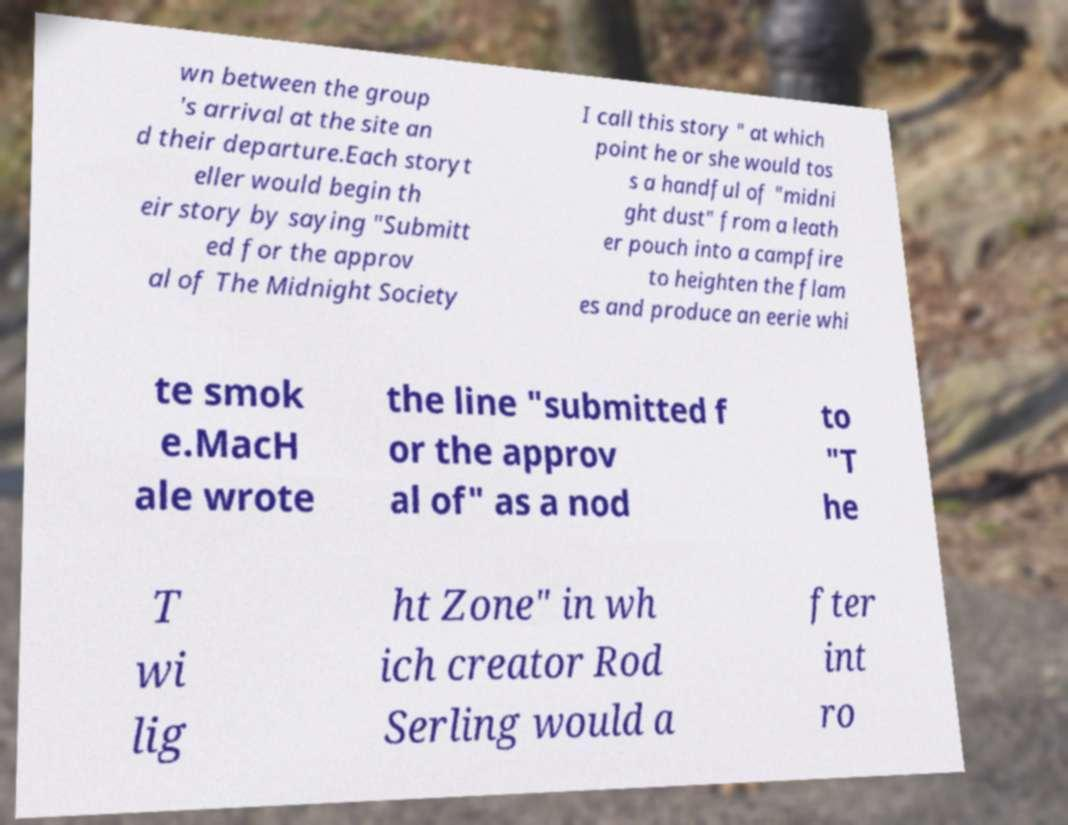Please identify and transcribe the text found in this image. wn between the group 's arrival at the site an d their departure.Each storyt eller would begin th eir story by saying "Submitt ed for the approv al of The Midnight Society I call this story " at which point he or she would tos s a handful of "midni ght dust" from a leath er pouch into a campfire to heighten the flam es and produce an eerie whi te smok e.MacH ale wrote the line "submitted f or the approv al of" as a nod to "T he T wi lig ht Zone" in wh ich creator Rod Serling would a fter int ro 